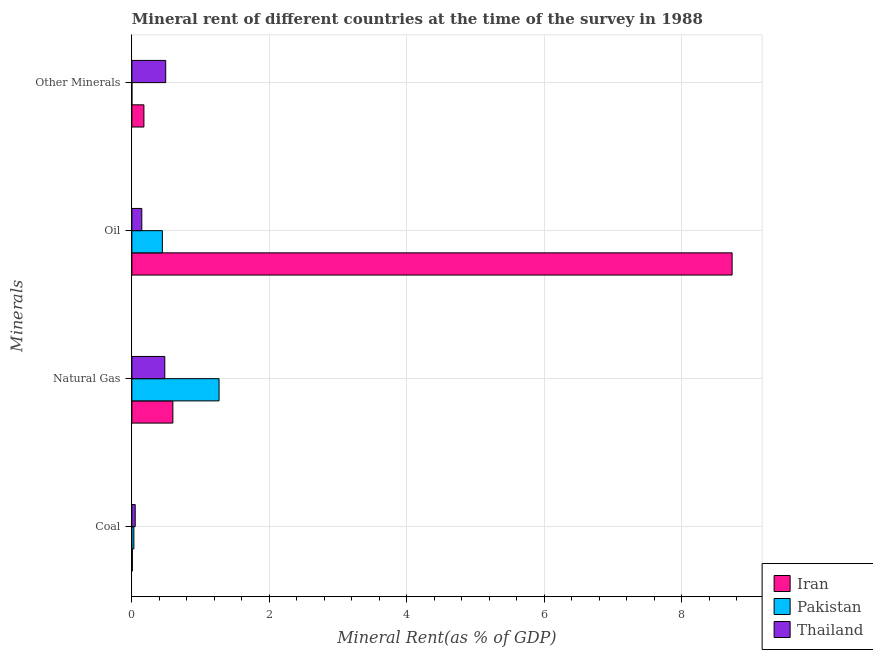How many different coloured bars are there?
Give a very brief answer. 3. Are the number of bars on each tick of the Y-axis equal?
Your answer should be compact. Yes. How many bars are there on the 2nd tick from the bottom?
Give a very brief answer. 3. What is the label of the 3rd group of bars from the top?
Ensure brevity in your answer.  Natural Gas. What is the natural gas rent in Iran?
Offer a very short reply. 0.6. Across all countries, what is the maximum  rent of other minerals?
Your answer should be compact. 0.49. Across all countries, what is the minimum coal rent?
Make the answer very short. 0.01. In which country was the natural gas rent maximum?
Give a very brief answer. Pakistan. In which country was the coal rent minimum?
Offer a terse response. Iran. What is the total  rent of other minerals in the graph?
Provide a short and direct response. 0.67. What is the difference between the coal rent in Iran and that in Pakistan?
Your answer should be very brief. -0.02. What is the difference between the  rent of other minerals in Iran and the coal rent in Thailand?
Provide a succinct answer. 0.13. What is the average  rent of other minerals per country?
Give a very brief answer. 0.22. What is the difference between the  rent of other minerals and coal rent in Thailand?
Make the answer very short. 0.44. In how many countries, is the natural gas rent greater than 6.4 %?
Keep it short and to the point. 0. What is the ratio of the oil rent in Thailand to that in Iran?
Ensure brevity in your answer.  0.02. Is the oil rent in Iran less than that in Pakistan?
Ensure brevity in your answer.  No. Is the difference between the  rent of other minerals in Pakistan and Iran greater than the difference between the oil rent in Pakistan and Iran?
Your answer should be compact. Yes. What is the difference between the highest and the second highest oil rent?
Ensure brevity in your answer.  8.29. What is the difference between the highest and the lowest oil rent?
Your response must be concise. 8.59. Is the sum of the oil rent in Pakistan and Iran greater than the maximum coal rent across all countries?
Your response must be concise. Yes. What does the 1st bar from the top in Oil represents?
Your answer should be compact. Thailand. What does the 1st bar from the bottom in Coal represents?
Your response must be concise. Iran. Is it the case that in every country, the sum of the coal rent and natural gas rent is greater than the oil rent?
Your answer should be compact. No. How many bars are there?
Keep it short and to the point. 12. Does the graph contain any zero values?
Keep it short and to the point. No. How many legend labels are there?
Your response must be concise. 3. How are the legend labels stacked?
Your answer should be compact. Vertical. What is the title of the graph?
Your response must be concise. Mineral rent of different countries at the time of the survey in 1988. What is the label or title of the X-axis?
Offer a very short reply. Mineral Rent(as % of GDP). What is the label or title of the Y-axis?
Your response must be concise. Minerals. What is the Mineral Rent(as % of GDP) of Iran in Coal?
Offer a very short reply. 0.01. What is the Mineral Rent(as % of GDP) in Pakistan in Coal?
Provide a short and direct response. 0.03. What is the Mineral Rent(as % of GDP) of Thailand in Coal?
Provide a succinct answer. 0.05. What is the Mineral Rent(as % of GDP) of Iran in Natural Gas?
Offer a very short reply. 0.6. What is the Mineral Rent(as % of GDP) in Pakistan in Natural Gas?
Offer a very short reply. 1.27. What is the Mineral Rent(as % of GDP) of Thailand in Natural Gas?
Your response must be concise. 0.48. What is the Mineral Rent(as % of GDP) in Iran in Oil?
Ensure brevity in your answer.  8.73. What is the Mineral Rent(as % of GDP) in Pakistan in Oil?
Offer a very short reply. 0.44. What is the Mineral Rent(as % of GDP) in Thailand in Oil?
Provide a succinct answer. 0.14. What is the Mineral Rent(as % of GDP) in Iran in Other Minerals?
Your response must be concise. 0.17. What is the Mineral Rent(as % of GDP) in Pakistan in Other Minerals?
Make the answer very short. 0. What is the Mineral Rent(as % of GDP) of Thailand in Other Minerals?
Provide a short and direct response. 0.49. Across all Minerals, what is the maximum Mineral Rent(as % of GDP) of Iran?
Give a very brief answer. 8.73. Across all Minerals, what is the maximum Mineral Rent(as % of GDP) of Pakistan?
Ensure brevity in your answer.  1.27. Across all Minerals, what is the maximum Mineral Rent(as % of GDP) of Thailand?
Your answer should be very brief. 0.49. Across all Minerals, what is the minimum Mineral Rent(as % of GDP) in Iran?
Keep it short and to the point. 0.01. Across all Minerals, what is the minimum Mineral Rent(as % of GDP) in Pakistan?
Your answer should be very brief. 0. Across all Minerals, what is the minimum Mineral Rent(as % of GDP) of Thailand?
Give a very brief answer. 0.05. What is the total Mineral Rent(as % of GDP) of Iran in the graph?
Your response must be concise. 9.51. What is the total Mineral Rent(as % of GDP) of Pakistan in the graph?
Make the answer very short. 1.74. What is the total Mineral Rent(as % of GDP) of Thailand in the graph?
Your response must be concise. 1.16. What is the difference between the Mineral Rent(as % of GDP) in Iran in Coal and that in Natural Gas?
Provide a short and direct response. -0.59. What is the difference between the Mineral Rent(as % of GDP) in Pakistan in Coal and that in Natural Gas?
Offer a terse response. -1.24. What is the difference between the Mineral Rent(as % of GDP) of Thailand in Coal and that in Natural Gas?
Ensure brevity in your answer.  -0.43. What is the difference between the Mineral Rent(as % of GDP) in Iran in Coal and that in Oil?
Give a very brief answer. -8.72. What is the difference between the Mineral Rent(as % of GDP) in Pakistan in Coal and that in Oil?
Your response must be concise. -0.41. What is the difference between the Mineral Rent(as % of GDP) of Thailand in Coal and that in Oil?
Offer a terse response. -0.1. What is the difference between the Mineral Rent(as % of GDP) in Iran in Coal and that in Other Minerals?
Offer a very short reply. -0.17. What is the difference between the Mineral Rent(as % of GDP) of Pakistan in Coal and that in Other Minerals?
Offer a terse response. 0.03. What is the difference between the Mineral Rent(as % of GDP) in Thailand in Coal and that in Other Minerals?
Give a very brief answer. -0.44. What is the difference between the Mineral Rent(as % of GDP) of Iran in Natural Gas and that in Oil?
Your answer should be very brief. -8.13. What is the difference between the Mineral Rent(as % of GDP) in Pakistan in Natural Gas and that in Oil?
Give a very brief answer. 0.82. What is the difference between the Mineral Rent(as % of GDP) in Thailand in Natural Gas and that in Oil?
Offer a very short reply. 0.33. What is the difference between the Mineral Rent(as % of GDP) of Iran in Natural Gas and that in Other Minerals?
Offer a very short reply. 0.42. What is the difference between the Mineral Rent(as % of GDP) in Pakistan in Natural Gas and that in Other Minerals?
Provide a short and direct response. 1.27. What is the difference between the Mineral Rent(as % of GDP) of Thailand in Natural Gas and that in Other Minerals?
Your response must be concise. -0.01. What is the difference between the Mineral Rent(as % of GDP) of Iran in Oil and that in Other Minerals?
Provide a succinct answer. 8.55. What is the difference between the Mineral Rent(as % of GDP) of Pakistan in Oil and that in Other Minerals?
Offer a terse response. 0.44. What is the difference between the Mineral Rent(as % of GDP) in Thailand in Oil and that in Other Minerals?
Offer a very short reply. -0.35. What is the difference between the Mineral Rent(as % of GDP) of Iran in Coal and the Mineral Rent(as % of GDP) of Pakistan in Natural Gas?
Provide a succinct answer. -1.26. What is the difference between the Mineral Rent(as % of GDP) in Iran in Coal and the Mineral Rent(as % of GDP) in Thailand in Natural Gas?
Offer a terse response. -0.47. What is the difference between the Mineral Rent(as % of GDP) in Pakistan in Coal and the Mineral Rent(as % of GDP) in Thailand in Natural Gas?
Offer a terse response. -0.45. What is the difference between the Mineral Rent(as % of GDP) in Iran in Coal and the Mineral Rent(as % of GDP) in Pakistan in Oil?
Give a very brief answer. -0.44. What is the difference between the Mineral Rent(as % of GDP) of Iran in Coal and the Mineral Rent(as % of GDP) of Thailand in Oil?
Offer a terse response. -0.14. What is the difference between the Mineral Rent(as % of GDP) of Pakistan in Coal and the Mineral Rent(as % of GDP) of Thailand in Oil?
Offer a very short reply. -0.12. What is the difference between the Mineral Rent(as % of GDP) of Iran in Coal and the Mineral Rent(as % of GDP) of Pakistan in Other Minerals?
Your response must be concise. 0.01. What is the difference between the Mineral Rent(as % of GDP) of Iran in Coal and the Mineral Rent(as % of GDP) of Thailand in Other Minerals?
Your response must be concise. -0.49. What is the difference between the Mineral Rent(as % of GDP) in Pakistan in Coal and the Mineral Rent(as % of GDP) in Thailand in Other Minerals?
Provide a short and direct response. -0.46. What is the difference between the Mineral Rent(as % of GDP) of Iran in Natural Gas and the Mineral Rent(as % of GDP) of Pakistan in Oil?
Ensure brevity in your answer.  0.15. What is the difference between the Mineral Rent(as % of GDP) of Iran in Natural Gas and the Mineral Rent(as % of GDP) of Thailand in Oil?
Your answer should be very brief. 0.45. What is the difference between the Mineral Rent(as % of GDP) of Pakistan in Natural Gas and the Mineral Rent(as % of GDP) of Thailand in Oil?
Your answer should be compact. 1.12. What is the difference between the Mineral Rent(as % of GDP) of Iran in Natural Gas and the Mineral Rent(as % of GDP) of Pakistan in Other Minerals?
Make the answer very short. 0.6. What is the difference between the Mineral Rent(as % of GDP) of Iran in Natural Gas and the Mineral Rent(as % of GDP) of Thailand in Other Minerals?
Make the answer very short. 0.1. What is the difference between the Mineral Rent(as % of GDP) of Pakistan in Natural Gas and the Mineral Rent(as % of GDP) of Thailand in Other Minerals?
Provide a succinct answer. 0.78. What is the difference between the Mineral Rent(as % of GDP) of Iran in Oil and the Mineral Rent(as % of GDP) of Pakistan in Other Minerals?
Offer a terse response. 8.73. What is the difference between the Mineral Rent(as % of GDP) in Iran in Oil and the Mineral Rent(as % of GDP) in Thailand in Other Minerals?
Give a very brief answer. 8.24. What is the difference between the Mineral Rent(as % of GDP) of Pakistan in Oil and the Mineral Rent(as % of GDP) of Thailand in Other Minerals?
Give a very brief answer. -0.05. What is the average Mineral Rent(as % of GDP) in Iran per Minerals?
Offer a very short reply. 2.38. What is the average Mineral Rent(as % of GDP) of Pakistan per Minerals?
Your response must be concise. 0.44. What is the average Mineral Rent(as % of GDP) in Thailand per Minerals?
Your answer should be very brief. 0.29. What is the difference between the Mineral Rent(as % of GDP) in Iran and Mineral Rent(as % of GDP) in Pakistan in Coal?
Ensure brevity in your answer.  -0.02. What is the difference between the Mineral Rent(as % of GDP) in Iran and Mineral Rent(as % of GDP) in Thailand in Coal?
Keep it short and to the point. -0.04. What is the difference between the Mineral Rent(as % of GDP) in Pakistan and Mineral Rent(as % of GDP) in Thailand in Coal?
Your response must be concise. -0.02. What is the difference between the Mineral Rent(as % of GDP) of Iran and Mineral Rent(as % of GDP) of Pakistan in Natural Gas?
Offer a terse response. -0.67. What is the difference between the Mineral Rent(as % of GDP) in Iran and Mineral Rent(as % of GDP) in Thailand in Natural Gas?
Your response must be concise. 0.12. What is the difference between the Mineral Rent(as % of GDP) in Pakistan and Mineral Rent(as % of GDP) in Thailand in Natural Gas?
Ensure brevity in your answer.  0.79. What is the difference between the Mineral Rent(as % of GDP) in Iran and Mineral Rent(as % of GDP) in Pakistan in Oil?
Keep it short and to the point. 8.29. What is the difference between the Mineral Rent(as % of GDP) in Iran and Mineral Rent(as % of GDP) in Thailand in Oil?
Ensure brevity in your answer.  8.59. What is the difference between the Mineral Rent(as % of GDP) of Pakistan and Mineral Rent(as % of GDP) of Thailand in Oil?
Keep it short and to the point. 0.3. What is the difference between the Mineral Rent(as % of GDP) in Iran and Mineral Rent(as % of GDP) in Pakistan in Other Minerals?
Your response must be concise. 0.17. What is the difference between the Mineral Rent(as % of GDP) in Iran and Mineral Rent(as % of GDP) in Thailand in Other Minerals?
Your answer should be compact. -0.32. What is the difference between the Mineral Rent(as % of GDP) of Pakistan and Mineral Rent(as % of GDP) of Thailand in Other Minerals?
Ensure brevity in your answer.  -0.49. What is the ratio of the Mineral Rent(as % of GDP) in Iran in Coal to that in Natural Gas?
Your response must be concise. 0.01. What is the ratio of the Mineral Rent(as % of GDP) in Pakistan in Coal to that in Natural Gas?
Your answer should be compact. 0.02. What is the ratio of the Mineral Rent(as % of GDP) in Thailand in Coal to that in Natural Gas?
Provide a succinct answer. 0.1. What is the ratio of the Mineral Rent(as % of GDP) of Iran in Coal to that in Oil?
Your answer should be very brief. 0. What is the ratio of the Mineral Rent(as % of GDP) of Pakistan in Coal to that in Oil?
Your answer should be very brief. 0.07. What is the ratio of the Mineral Rent(as % of GDP) of Thailand in Coal to that in Oil?
Ensure brevity in your answer.  0.34. What is the ratio of the Mineral Rent(as % of GDP) of Iran in Coal to that in Other Minerals?
Ensure brevity in your answer.  0.04. What is the ratio of the Mineral Rent(as % of GDP) in Pakistan in Coal to that in Other Minerals?
Your answer should be very brief. 180.05. What is the ratio of the Mineral Rent(as % of GDP) of Thailand in Coal to that in Other Minerals?
Provide a short and direct response. 0.1. What is the ratio of the Mineral Rent(as % of GDP) of Iran in Natural Gas to that in Oil?
Your response must be concise. 0.07. What is the ratio of the Mineral Rent(as % of GDP) of Pakistan in Natural Gas to that in Oil?
Make the answer very short. 2.86. What is the ratio of the Mineral Rent(as % of GDP) of Thailand in Natural Gas to that in Oil?
Your response must be concise. 3.32. What is the ratio of the Mineral Rent(as % of GDP) of Iran in Natural Gas to that in Other Minerals?
Your answer should be compact. 3.41. What is the ratio of the Mineral Rent(as % of GDP) in Pakistan in Natural Gas to that in Other Minerals?
Your answer should be very brief. 7801.96. What is the ratio of the Mineral Rent(as % of GDP) in Thailand in Natural Gas to that in Other Minerals?
Your answer should be very brief. 0.97. What is the ratio of the Mineral Rent(as % of GDP) in Iran in Oil to that in Other Minerals?
Your answer should be compact. 49.9. What is the ratio of the Mineral Rent(as % of GDP) of Pakistan in Oil to that in Other Minerals?
Give a very brief answer. 2730.04. What is the ratio of the Mineral Rent(as % of GDP) in Thailand in Oil to that in Other Minerals?
Keep it short and to the point. 0.29. What is the difference between the highest and the second highest Mineral Rent(as % of GDP) of Iran?
Offer a very short reply. 8.13. What is the difference between the highest and the second highest Mineral Rent(as % of GDP) of Pakistan?
Your answer should be very brief. 0.82. What is the difference between the highest and the second highest Mineral Rent(as % of GDP) of Thailand?
Provide a succinct answer. 0.01. What is the difference between the highest and the lowest Mineral Rent(as % of GDP) in Iran?
Your response must be concise. 8.72. What is the difference between the highest and the lowest Mineral Rent(as % of GDP) in Pakistan?
Offer a terse response. 1.27. What is the difference between the highest and the lowest Mineral Rent(as % of GDP) in Thailand?
Your answer should be very brief. 0.44. 